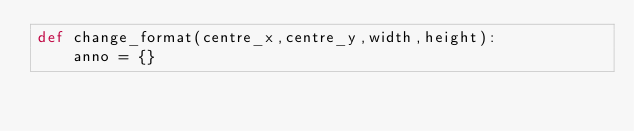<code> <loc_0><loc_0><loc_500><loc_500><_Python_>def change_format(centre_x,centre_y,width,height):
    anno = {}</code> 